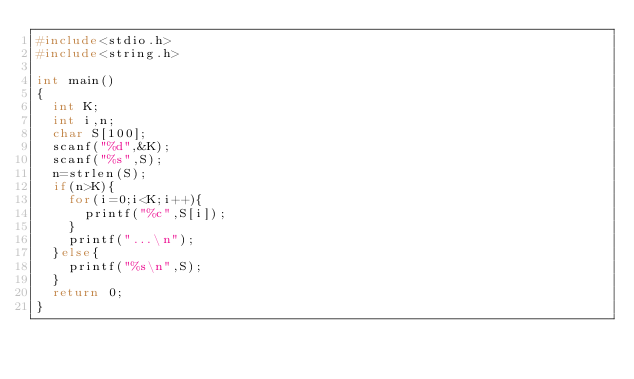<code> <loc_0><loc_0><loc_500><loc_500><_C_>#include<stdio.h>
#include<string.h>

int main()
{
  int K;
  int i,n;
  char S[100];
  scanf("%d",&K);
  scanf("%s",S);
  n=strlen(S);
  if(n>K){
    for(i=0;i<K;i++){
      printf("%c",S[i]);
    }
    printf("...\n");
  }else{
    printf("%s\n",S);
  }
  return 0;
}
</code> 